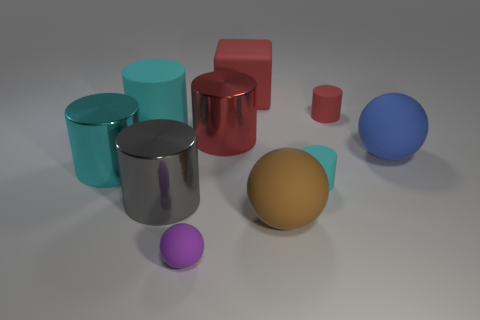Subtract all cyan cylinders. How many were subtracted if there are1cyan cylinders left? 2 Subtract all yellow balls. How many cyan cylinders are left? 3 Subtract all red cylinders. How many cylinders are left? 4 Subtract all large cyan cylinders. How many cylinders are left? 4 Subtract all yellow cylinders. Subtract all cyan spheres. How many cylinders are left? 6 Subtract all spheres. How many objects are left? 7 Subtract 0 purple cubes. How many objects are left? 10 Subtract all metal cylinders. Subtract all large brown balls. How many objects are left? 6 Add 2 rubber cylinders. How many rubber cylinders are left? 5 Add 4 tiny blue metallic cylinders. How many tiny blue metallic cylinders exist? 4 